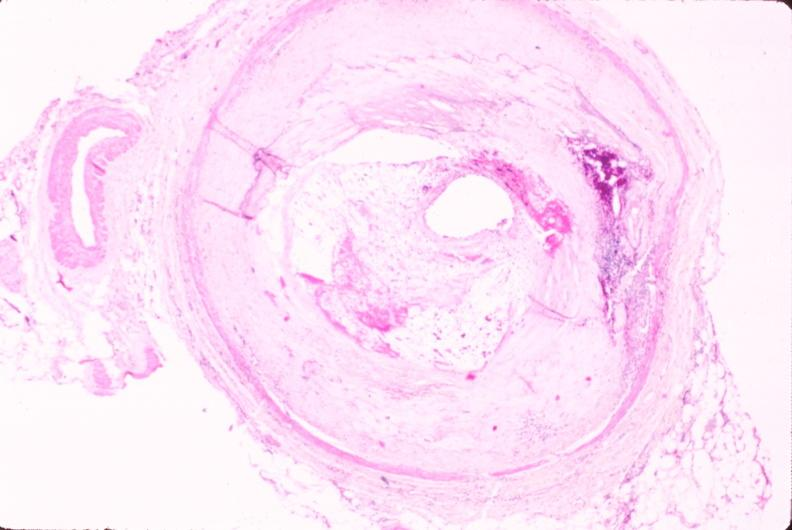what is present?
Answer the question using a single word or phrase. Vasculature 